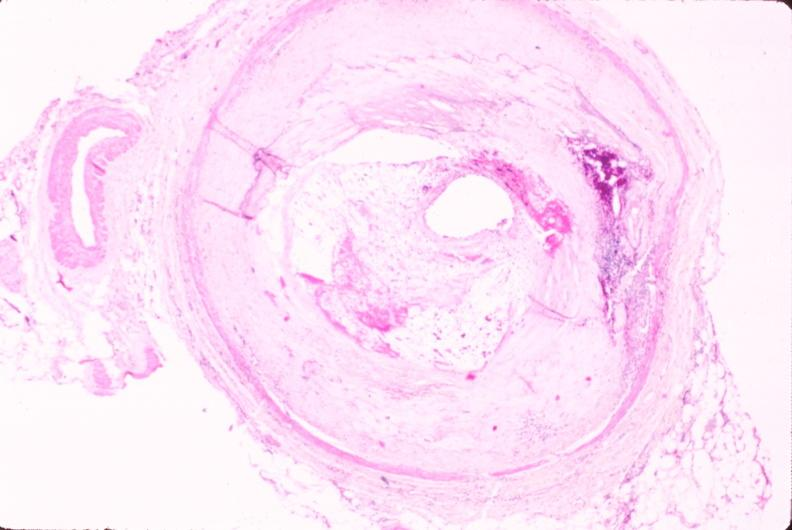what is present?
Answer the question using a single word or phrase. Vasculature 